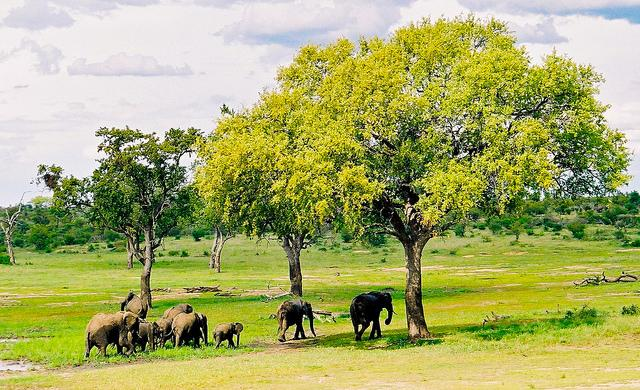How many elephants are there to lead this herd?

Choices:
A) four
B) three
C) two
D) one two 